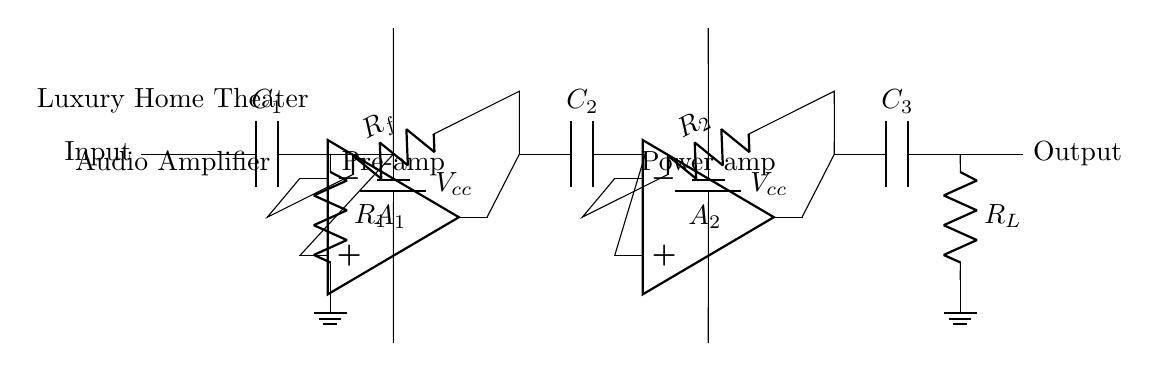What is the input component in this circuit? The input component is a capacitor connected at the beginning of the circuit to couple the audio signal. It helps block any DC voltage while allowing AC signals to pass through.
Answer: Capacitor What is the role of the operational amplifiers? The operational amplifiers serve to amplify the audio signal. There are two stages of amplification in this circuit, allowing for increased gain before the output stage.
Answer: Amplification What type of audio amplifier is represented in the diagram? The diagram represents an analog audio amplifier, which processes continuous signals for high-quality audio output.
Answer: Analog What does the label R_L represent? R_L represents the load resistor, which is connected at the output stage and is essential for ensuring the amplifier has an appropriate load for efficient operation.
Answer: Load resistor How many amplification stages are present in this circuit? There are two amplification stages, indicated by the two operational amplifiers in the circuit. Each stage amplifies the signal further.
Answer: Two What is the purpose of the capacitors in this circuit? The capacitors are used for various purposes such as coupling (to block DC components) and decoupling (to stabilize the power supply), ensuring a clean audio signal.
Answer: Coupling and decoupling What might happen if the load resistor is too low? If the load resistor is too low, it can lead to excessive current draw from the amplifier, potentially causing distortion or damaging the amplifier due to overheating.
Answer: Distortion or damage 